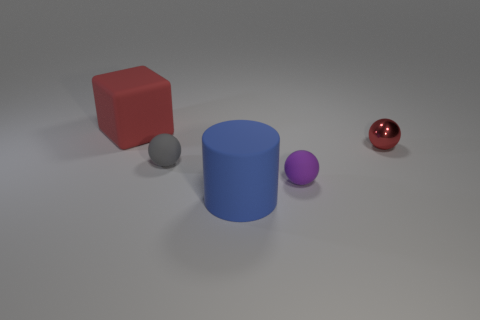Add 5 tiny gray spheres. How many objects exist? 10 Subtract all blocks. How many objects are left? 4 Subtract 0 red cylinders. How many objects are left? 5 Subtract all large green blocks. Subtract all large cylinders. How many objects are left? 4 Add 4 tiny red spheres. How many tiny red spheres are left? 5 Add 5 gray spheres. How many gray spheres exist? 6 